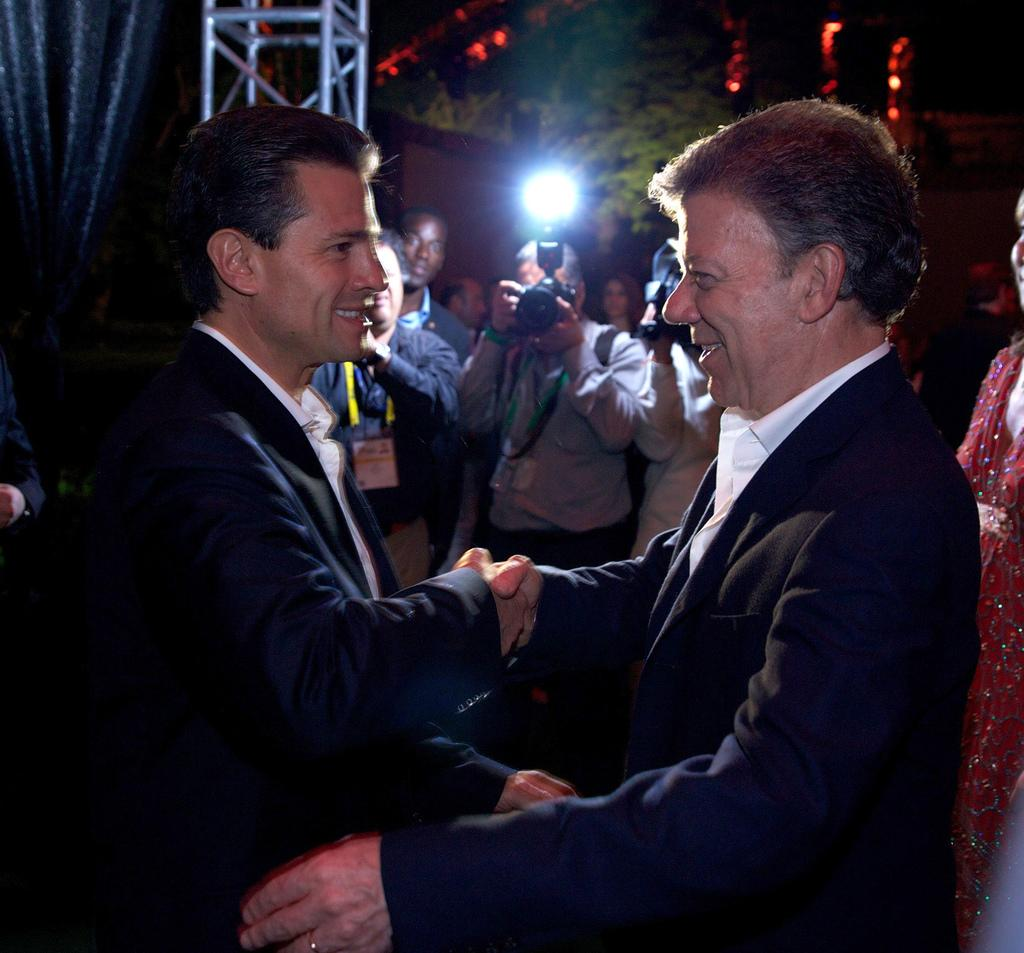Who or what can be seen in the image? There are people in the image. What object is present that is typically used for capturing images? There is a camera in the image. What type of natural vegetation is visible in the image? There are trees in the image. How would you describe the lighting in the image? The image is slightly dark. What type of ring can be seen on the grandfather's finger in the image? There is no grandfather or ring present in the image. How does the honey taste in the image? There is no honey present in the image. 